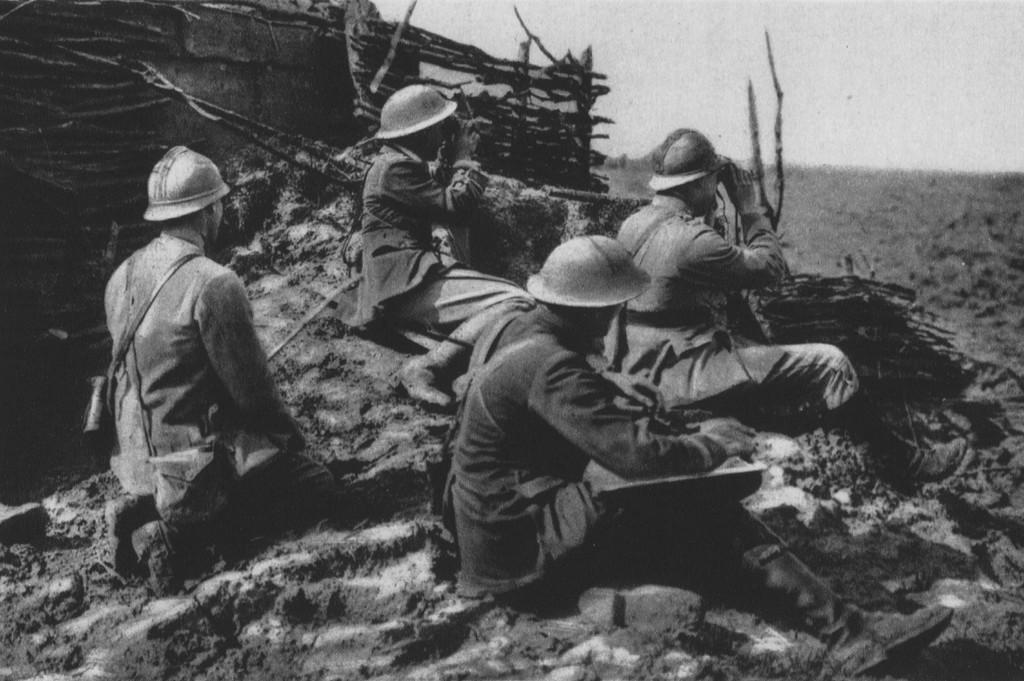How many people are sitting on the floor in the image? There are four people sitting on the floor in the image. What can be seen on the left side of the image? There is an object on the left side of the image. What is the condition of the sky in the image? The sky is clear in the image. What color scheme is used in the image? The image is in black and white. What type of rice is being cooked by the people sitting on the floor in the image? There is no rice present in the image; the people are sitting on the floor without any cooking activity. 